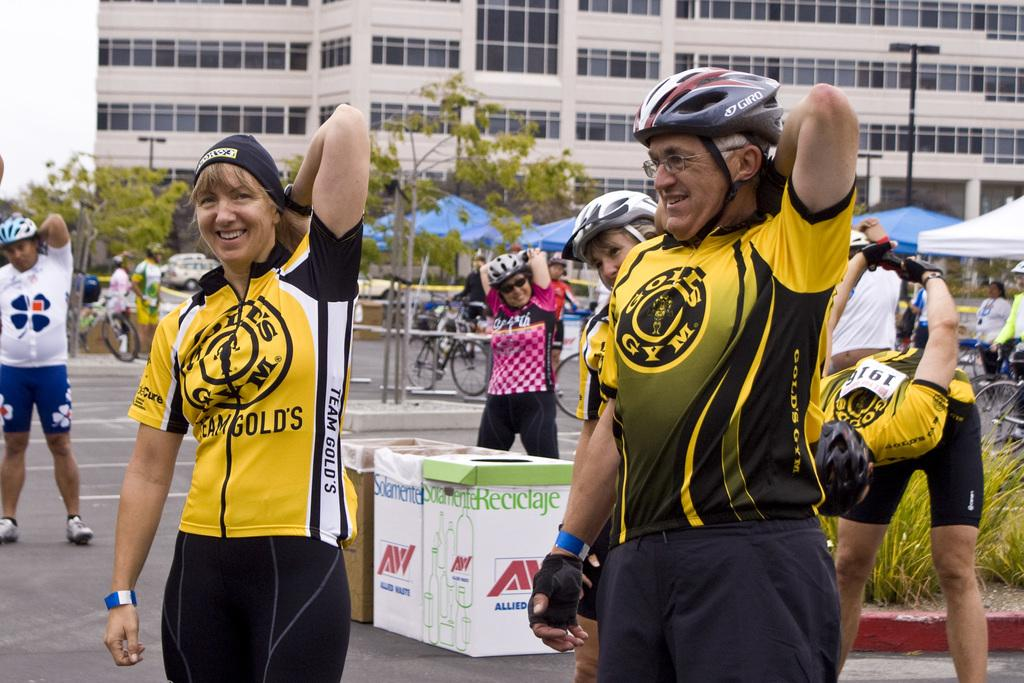How many people can be seen in the image? There are people standing in the image. Can you describe the clothing of one of the people? One person is wearing a cap. What objects are present on the road in the image? Cardboard boxes are present on the road. What can be seen in the background of the image? There are trees, tents, bicycles, buildings, and the sky visible in the background of the image. What type of spring can be seen in the image? There is no spring present in the image. Can you tell me how many kittens are playing with the bicycles in the background? There are: There are no kittens present in the image, and therefore no such activity can be observed. 